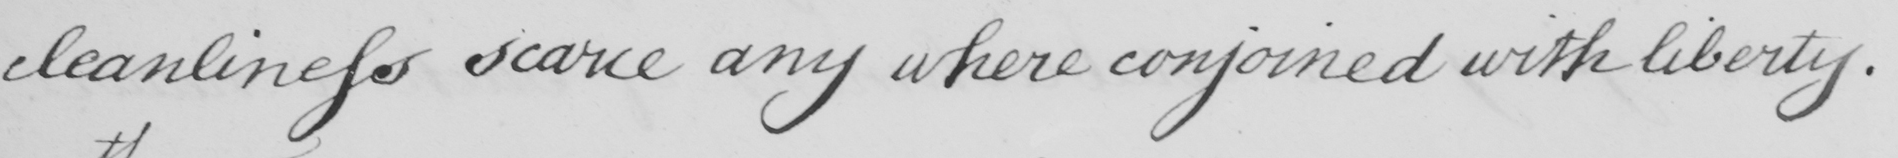Please transcribe the handwritten text in this image. cleanliness scarce any where conjoined with liberty. 